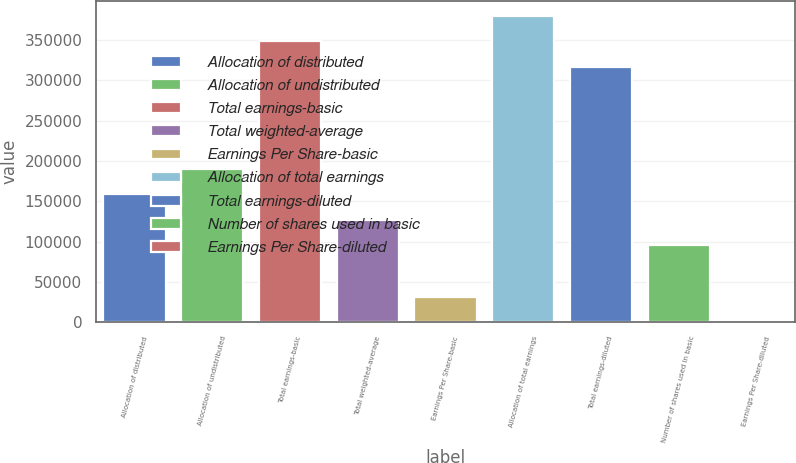<chart> <loc_0><loc_0><loc_500><loc_500><bar_chart><fcel>Allocation of distributed<fcel>Allocation of undistributed<fcel>Total earnings-basic<fcel>Total weighted-average<fcel>Earnings Per Share-basic<fcel>Allocation of total earnings<fcel>Total earnings-diluted<fcel>Number of shares used in basic<fcel>Earnings Per Share-diluted<nl><fcel>158732<fcel>190477<fcel>348400<fcel>126986<fcel>31750.5<fcel>380146<fcel>316655<fcel>95241.1<fcel>5.22<nl></chart> 